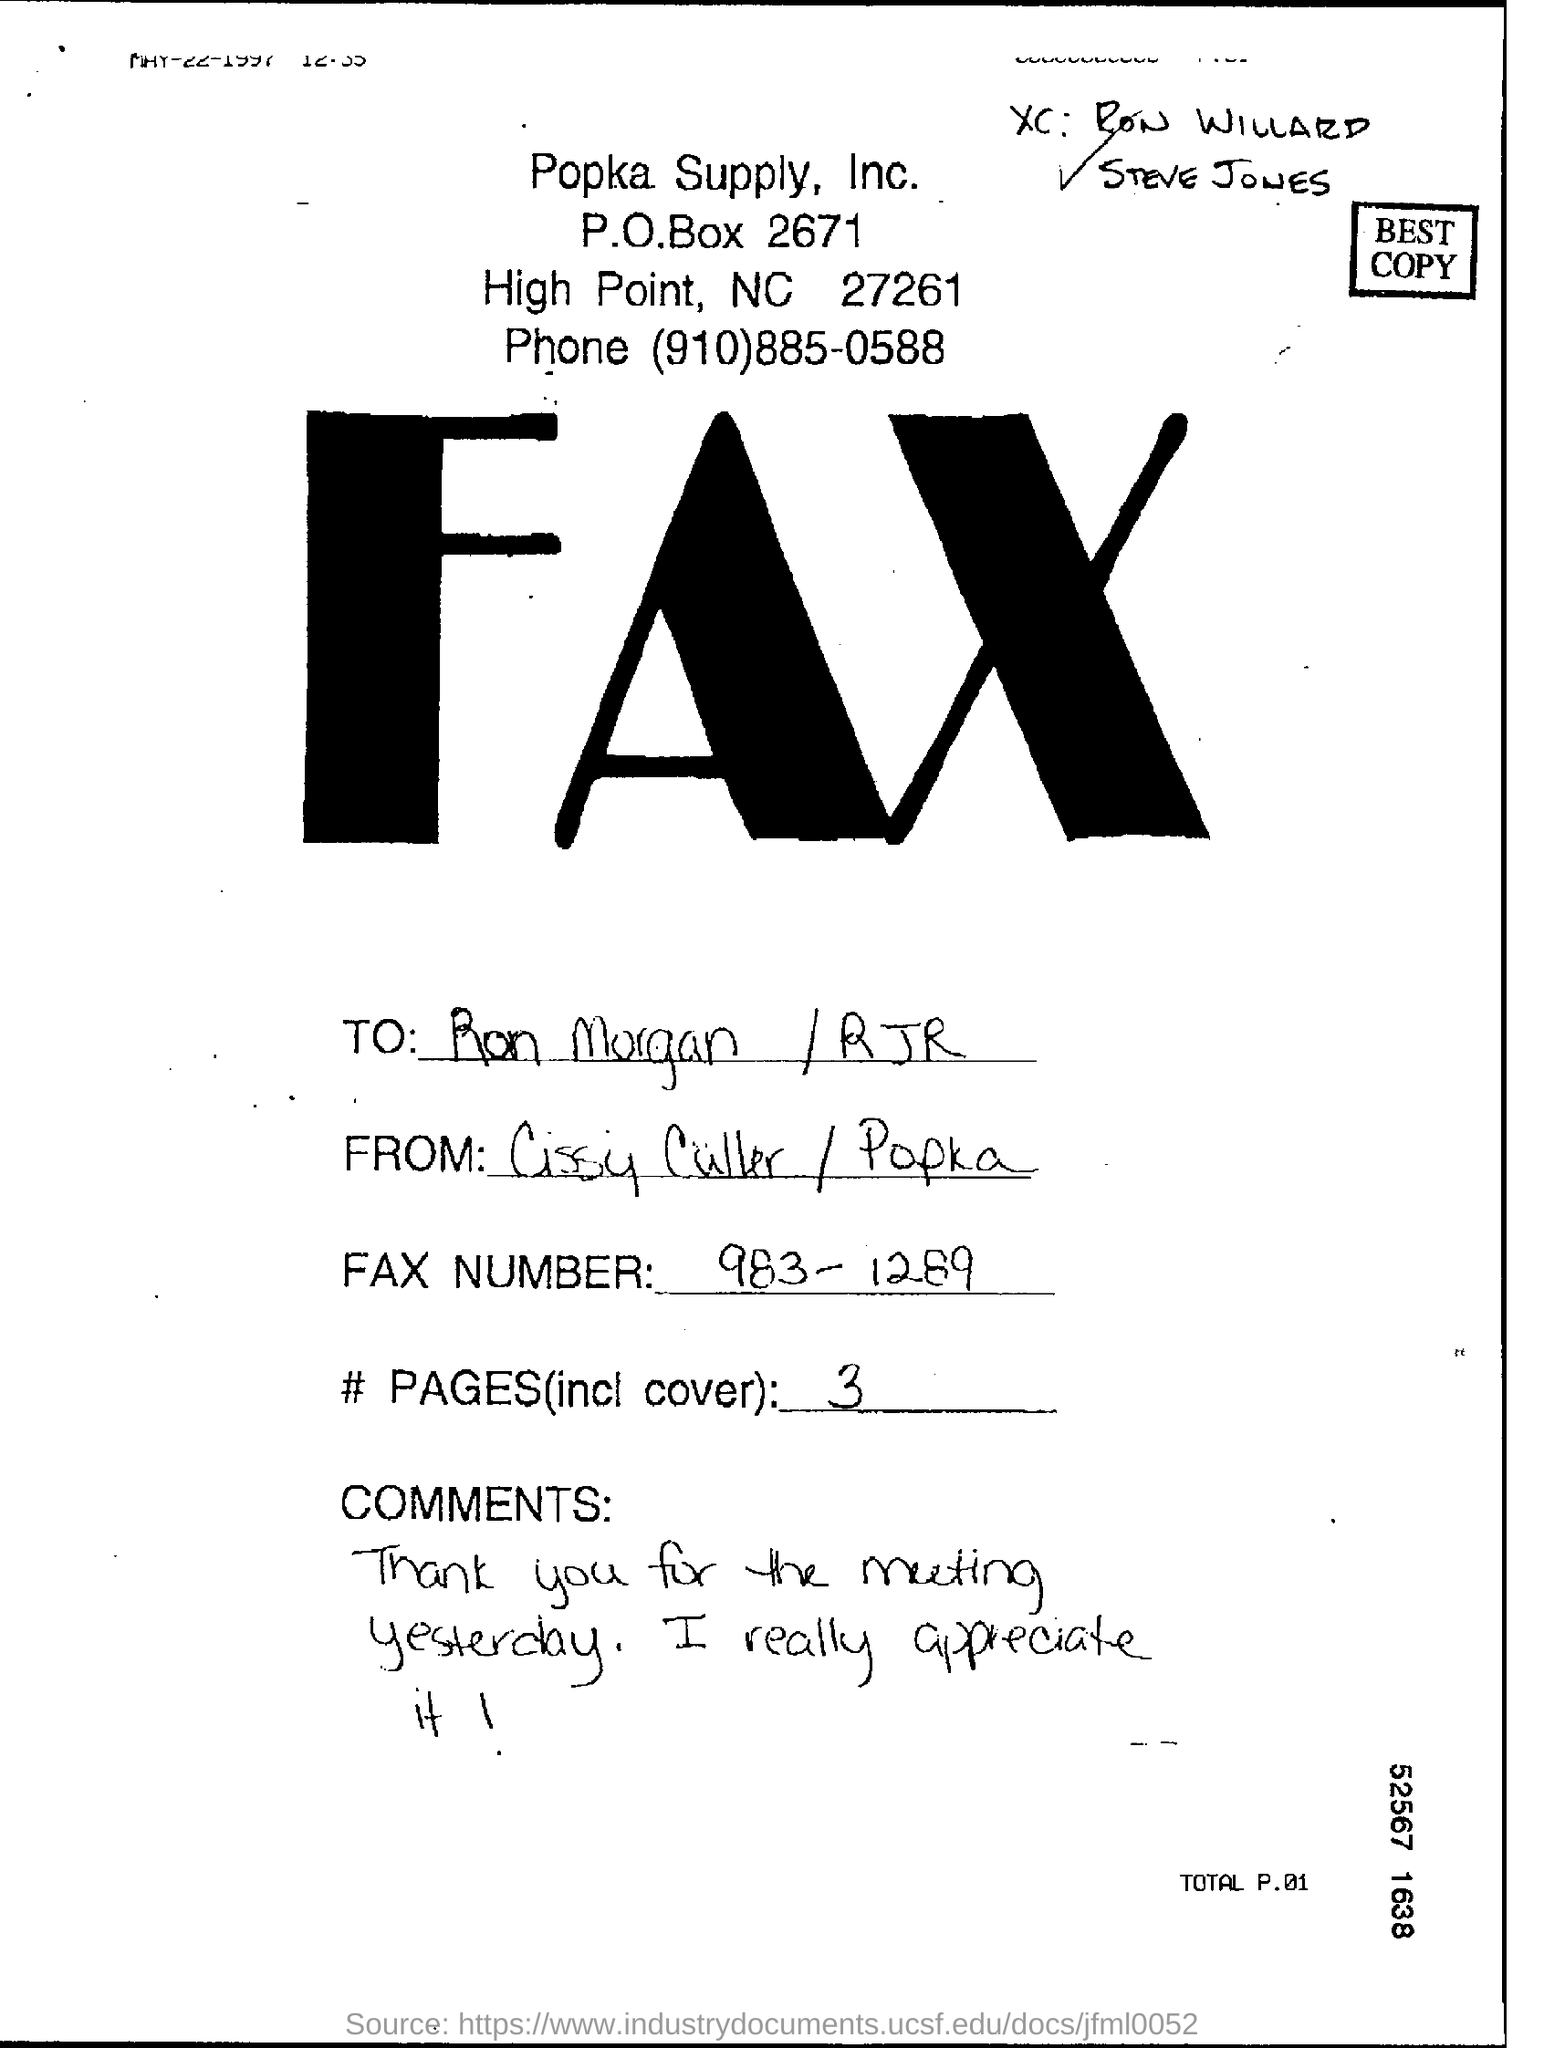Highlight a few significant elements in this photo. The fax is addressed to Ron Morgan/RJR. The name of the company appearing at the top of the page is Popka Supply, Inc. There are 3 pages, including the cover. 